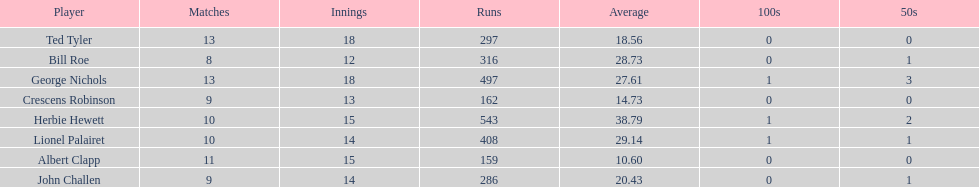Name a player that play in no more than 13 innings. Bill Roe. 